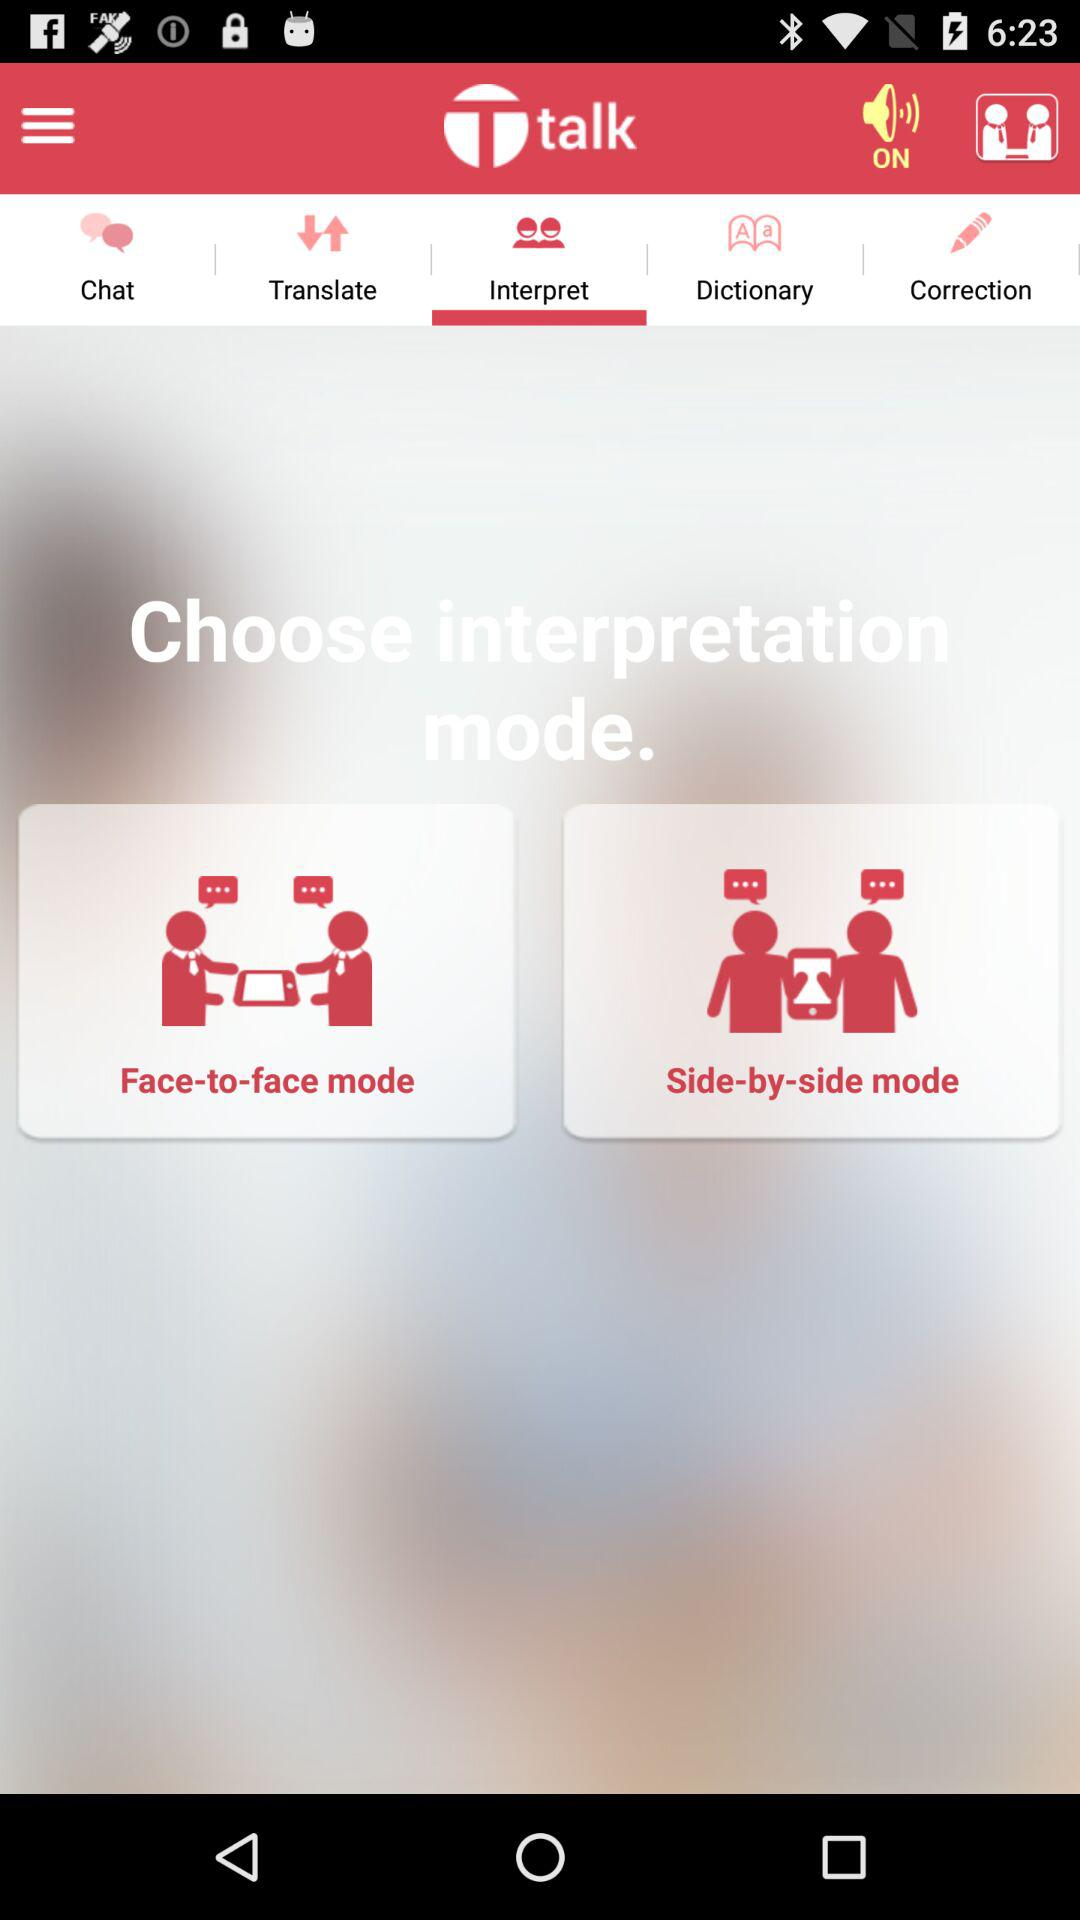What is the name of the application? The name of the application is "Ttalk". 